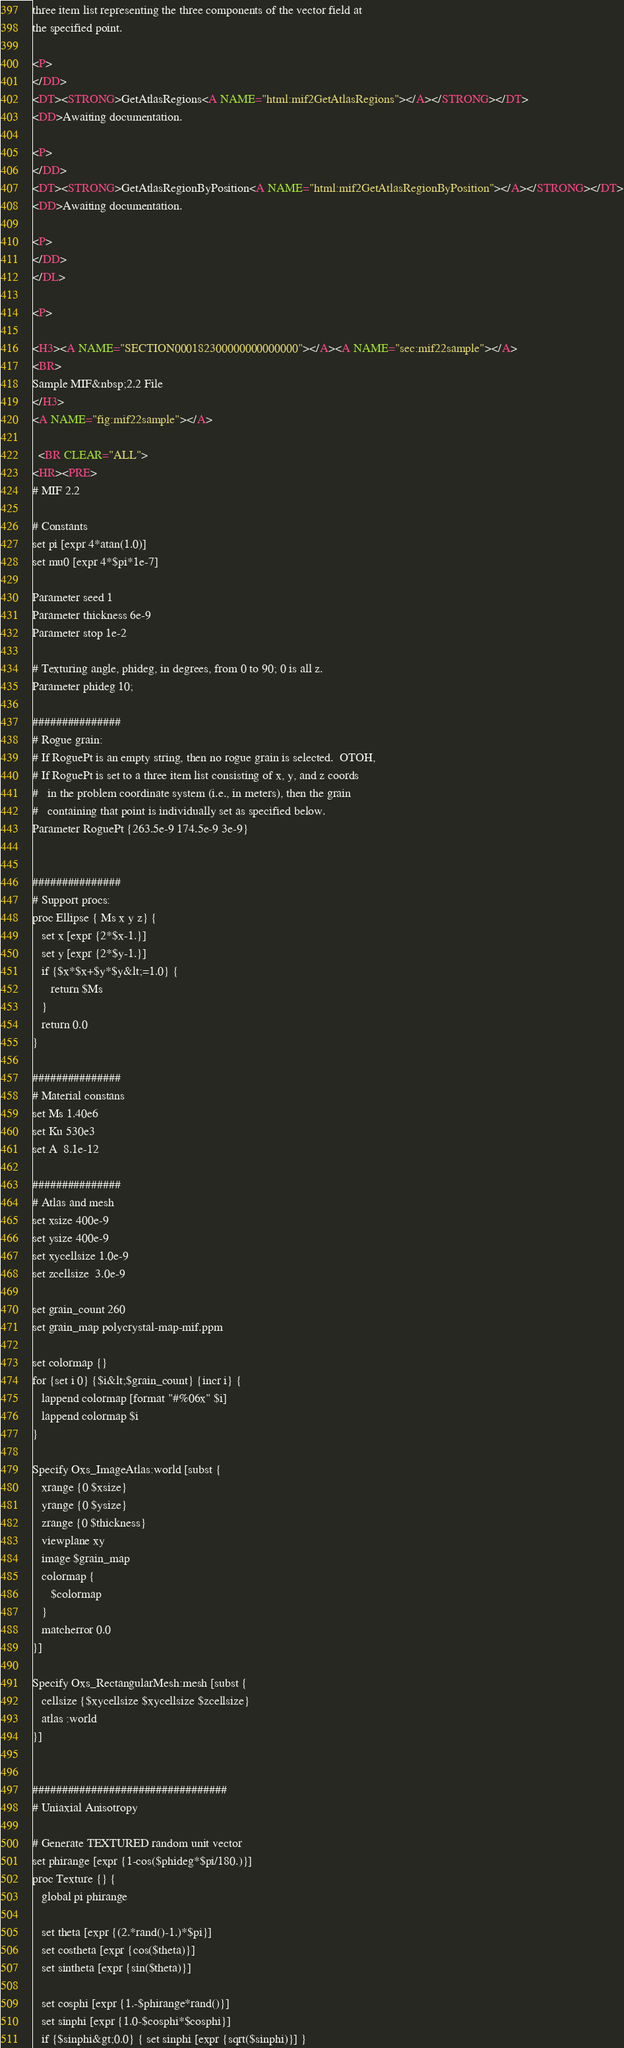Convert code to text. <code><loc_0><loc_0><loc_500><loc_500><_HTML_>three item list representing the three components of the vector field at
the specified point.

<P>
</DD>
<DT><STRONG>GetAtlasRegions<A NAME="html:mif2GetAtlasRegions"></A></STRONG></DT>
<DD>Awaiting documentation.

<P>
</DD>
<DT><STRONG>GetAtlasRegionByPosition<A NAME="html:mif2GetAtlasRegionByPosition"></A></STRONG></DT>
<DD>Awaiting documentation.

<P>
</DD>
</DL>

<P>

<H3><A NAME="SECTION000182300000000000000"></A><A NAME="sec:mif22sample"></A>
<BR>
Sample MIF&nbsp;2.2 File
</H3>
<A NAME="fig:mif22sample"></A>  
  
  <BR CLEAR="ALL">
<HR><PRE>
# MIF 2.2

# Constants
set pi [expr 4*atan(1.0)]
set mu0 [expr 4*$pi*1e-7]

Parameter seed 1
Parameter thickness 6e-9
Parameter stop 1e-2

# Texturing angle, phideg, in degrees, from 0 to 90; 0 is all z.
Parameter phideg 10;

###############
# Rogue grain:
# If RoguePt is an empty string, then no rogue grain is selected.  OTOH,
# If RoguePt is set to a three item list consisting of x, y, and z coords
#   in the problem coordinate system (i.e., in meters), then the grain
#   containing that point is individually set as specified below.
Parameter RoguePt {263.5e-9 174.5e-9 3e-9}


###############
# Support procs:
proc Ellipse { Ms x y z} {
   set x [expr {2*$x-1.}]
   set y [expr {2*$y-1.}]
   if {$x*$x+$y*$y&lt;=1.0} {
      return $Ms
   }
   return 0.0
}

###############
# Material constans
set Ms 1.40e6
set Ku 530e3
set A  8.1e-12

###############
# Atlas and mesh
set xsize 400e-9
set ysize 400e-9
set xycellsize 1.0e-9
set zcellsize  3.0e-9

set grain_count 260
set grain_map polycrystal-map-mif.ppm

set colormap {}
for {set i 0} {$i&lt;$grain_count} {incr i} {
   lappend colormap [format "#%06x" $i]
   lappend colormap $i
}

Specify Oxs_ImageAtlas:world [subst {
   xrange {0 $xsize}
   yrange {0 $ysize}
   zrange {0 $thickness}
   viewplane xy
   image $grain_map
   colormap {
      $colormap
   }
   matcherror 0.0
}]

Specify Oxs_RectangularMesh:mesh [subst {
   cellsize {$xycellsize $xycellsize $zcellsize}
   atlas :world
}]


#################################	
# Uniaxial Anisotropy

# Generate TEXTURED random unit vector
set phirange [expr {1-cos($phideg*$pi/180.)}]
proc Texture {} {
   global pi phirange

   set theta [expr {(2.*rand()-1.)*$pi}]
   set costheta [expr {cos($theta)}]
   set sintheta [expr {sin($theta)}]

   set cosphi [expr {1.-$phirange*rand()}]
   set sinphi [expr {1.0-$cosphi*$cosphi}]
   if {$sinphi&gt;0.0} { set sinphi [expr {sqrt($sinphi)}] }
</code> 